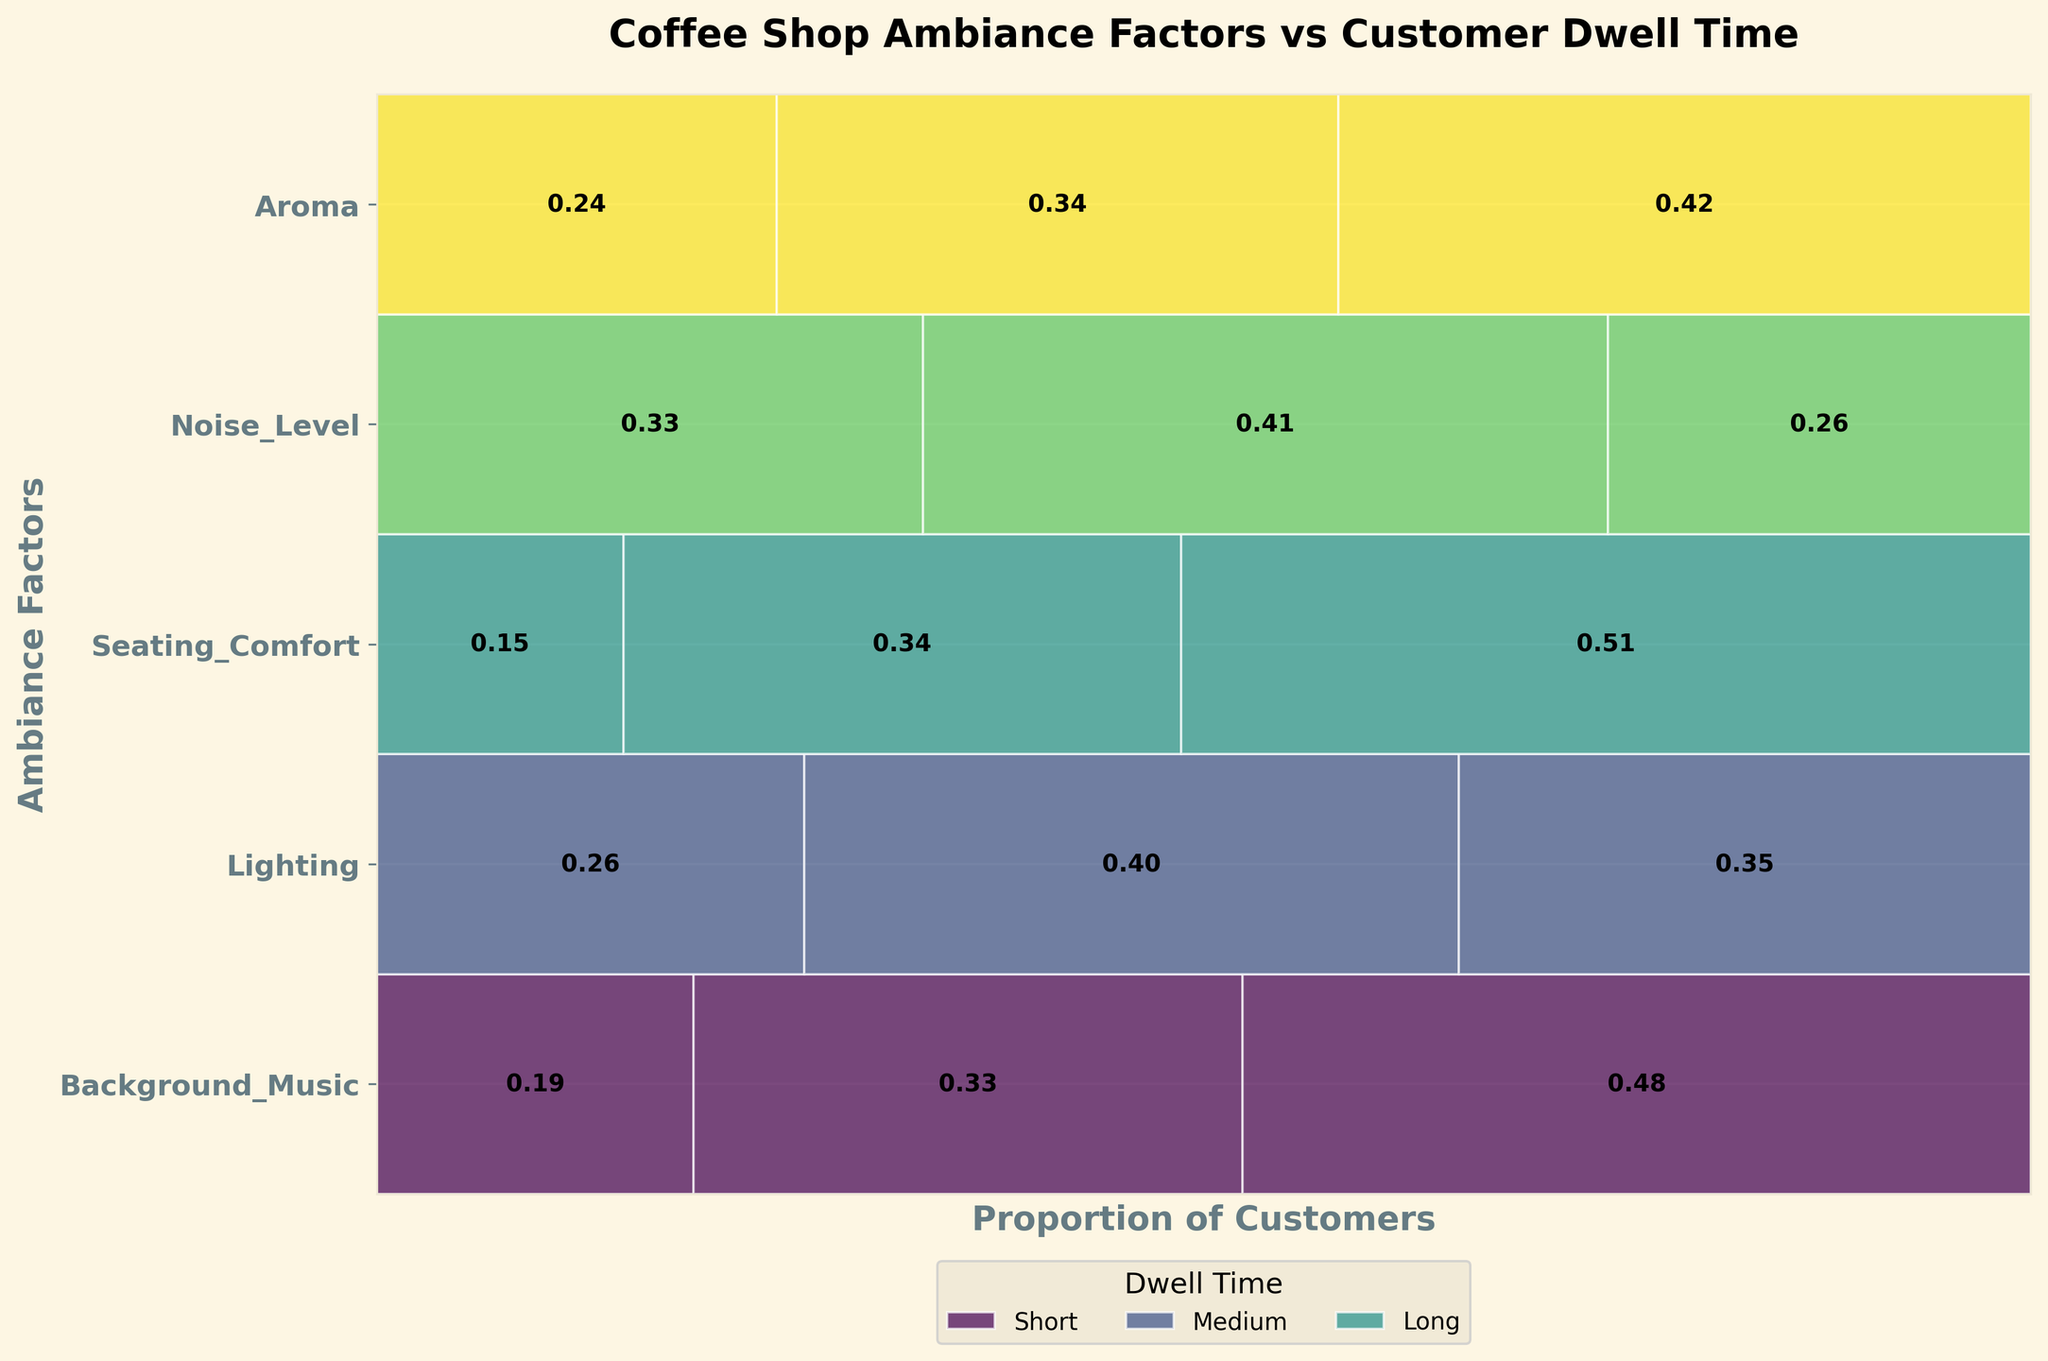Which ambiance factor has the highest proportion of customers with a long dwell time? Identify the ambiance factor with the highest proportion of customers in the "Long" category, which can be seen from the width of the respective rectangles.
Answer: Seating Comfort Which dwell time category has the smallest proportion of customers for Noise Level? Look at the rectangles corresponding to Noise Level and compare the widths. The narrowest rectangle corresponds to the category with the smallest proportion.
Answer: "Long" What's the total proportion of customers with a medium dwell time across all ambiance factors? Sum the proportions of customers in the "Medium" category for all ambiance factors. This involves adding the widths of each "Medium" rectangle.
Answer: 0.35 + 0.42 + 0.34 + 0.36 + 0.37 = 1.84 Does Aroma have a higher proportion of customers with a short dwell time than Lighting? Compare the widths of the "Short" dwell time rectangles for Aroma and Lighting.
Answer: No Which ambiance factor has the most balanced proportions across all dwell times? Identify the ambiance factor whose rectangles (Short, Medium, Long) are most similar in width.
Answer: Lighting What is the difference in proportion between customers with a short dwell time and long dwell time for Seating Comfort? Calculate the proportions of Seating Comfort for "Short" and "Long" and subtract the former from the latter.
Answer: 0.54 - 0.16 = 0.38 Which ambiance factor has the widest rectangle for medium dwell time? Identify the factor with the largest proportion rectangle in the "Medium" category.
Answer: Noise Level Is the proportion of customers with a short dwell time higher for Aroma or Background Music? Compare the respective widths of the "Short" rectangles for Aroma and Background Music.
Answer: Background Music What's the proportion of customers with a short dwell time across Lighting and Aroma combined? Add the proportions of customers with a short dwell time for Lighting and Aroma.
Answer: 0.20 + 0.22 = 0.42 